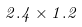Convert formula to latex. <formula><loc_0><loc_0><loc_500><loc_500>2 . 4 \times 1 . 2</formula> 